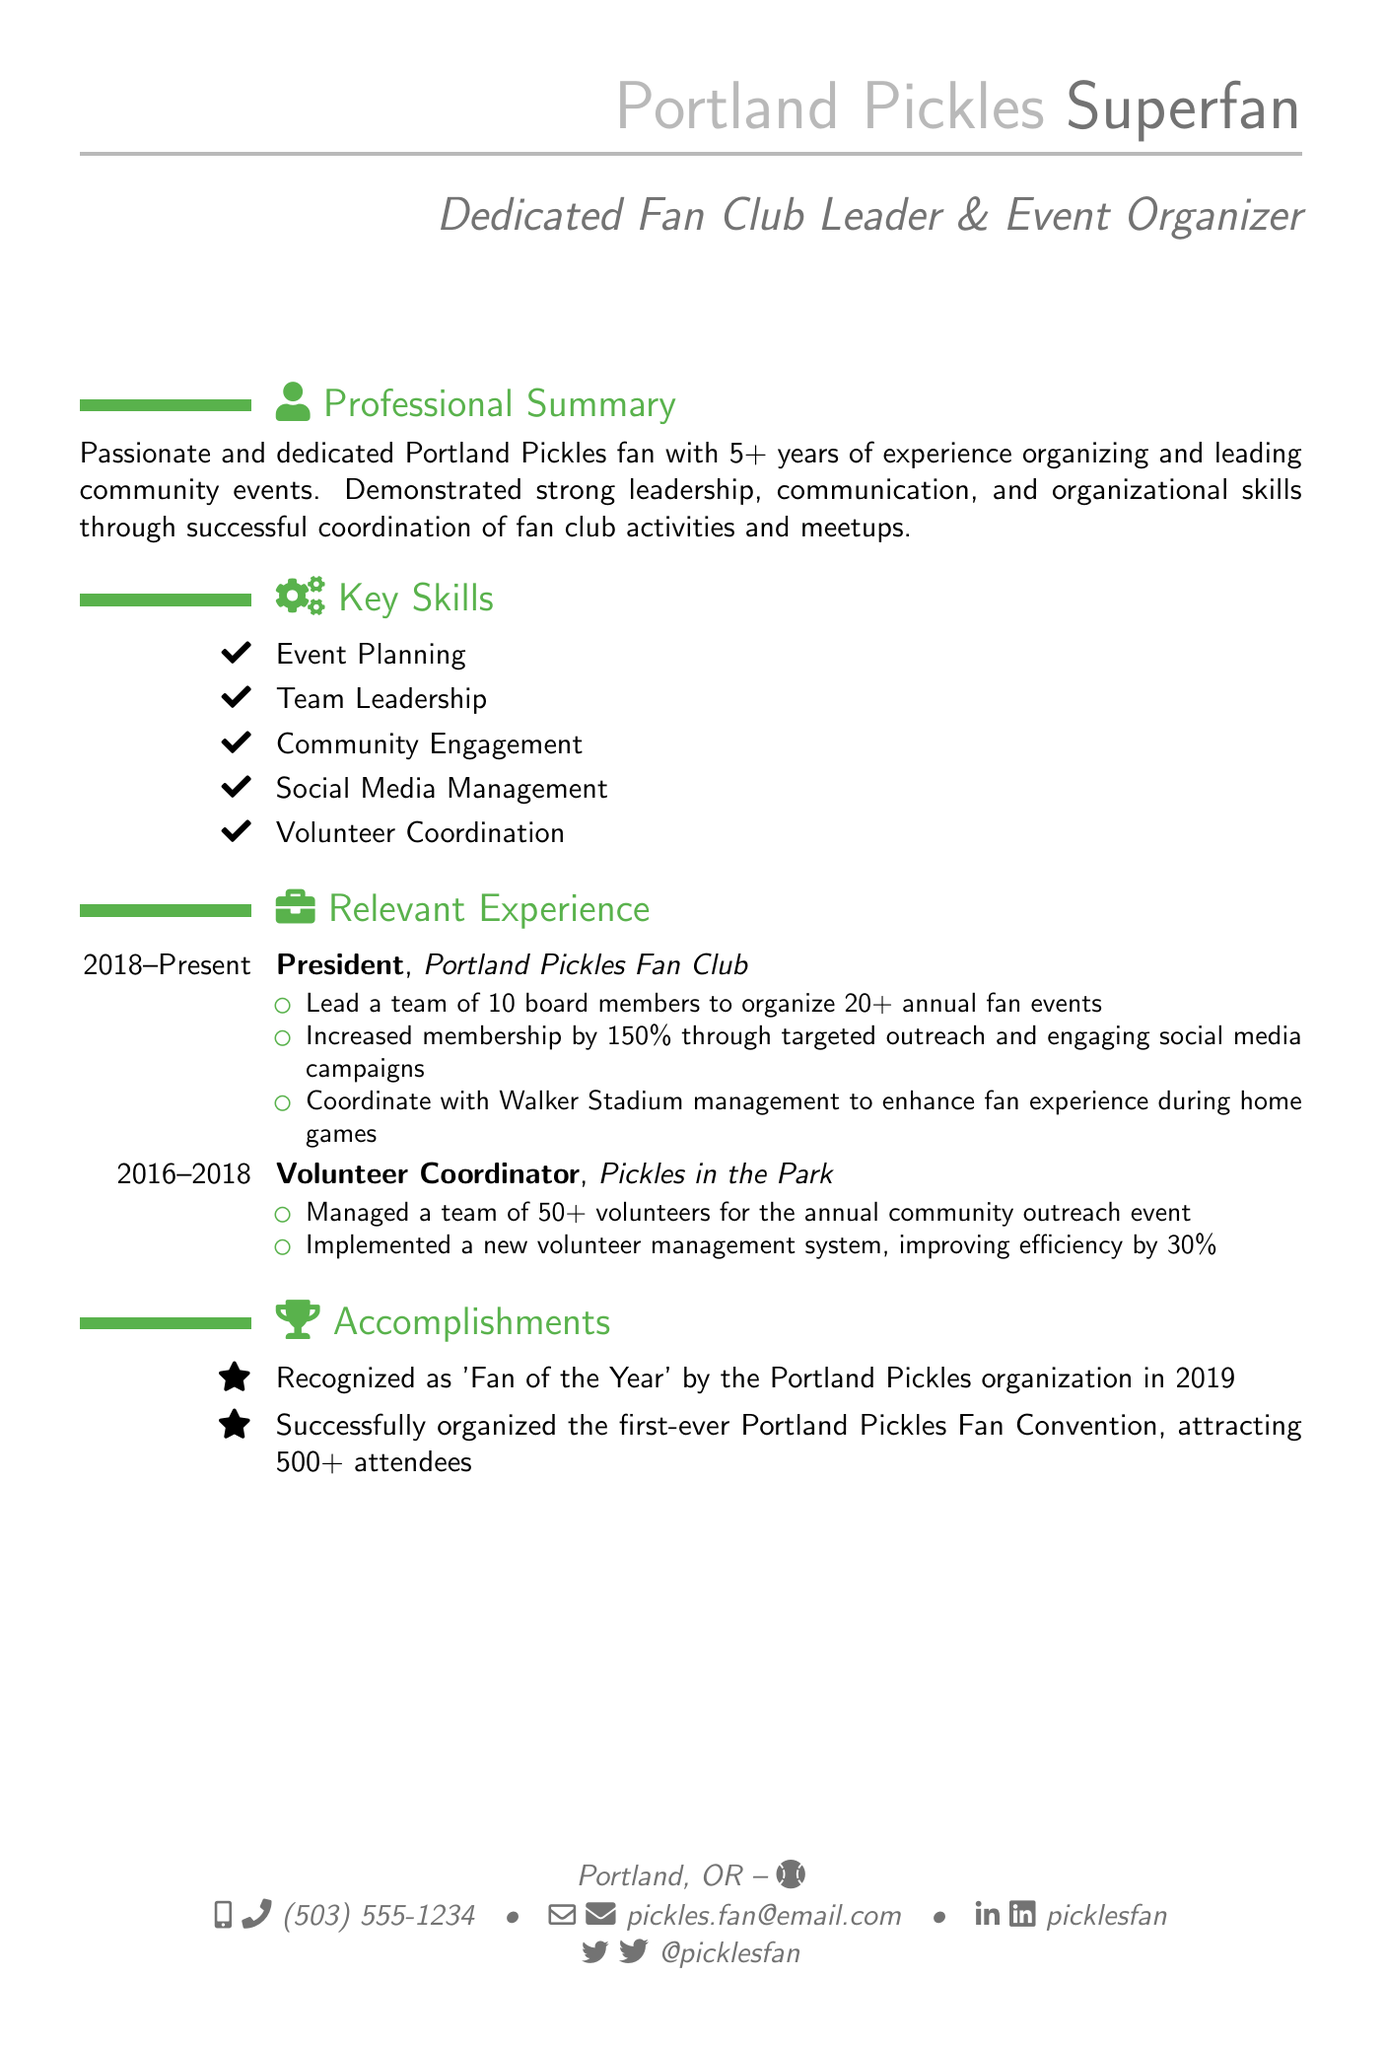What is the title of the position held at the Portland Pickles Fan Club? The title of the position held is indicated in the relevant experience section, which is "President."
Answer: President How many annual fan events are organized by the President? The number of annual fan events organized by the President is detailed in the responsibilities, which states "20+ annual fan events."
Answer: 20+ What percentage increase in membership was achieved? The percentage increase in membership is mentioned in the responsibilities as "150% through targeted outreach."
Answer: 150% What is one of the key skills listed in the resume? One of the key skills is highlighted under the key skills section, for example, "Event Planning."
Answer: Event Planning How many volunteers were managed during the Pickles in the Park event? The number of volunteers managed is specified in the relevant experience section as "50+ volunteers."
Answer: 50+ What recognition was received in 2019? The recognition received is stated in the accomplishments section, which mentions being "recognized as 'Fan of the Year' by the Portland Pickles organization."
Answer: Fan of the Year In what year did the President position at the Portland Pickles Fan Club begin? The starting year is provided in the relevant experience section and is noted as 2018.
Answer: 2018 What system was implemented to improve volunteer management? The system that was implemented is outlined in the relevant experience and referred to as a "new volunteer management system."
Answer: new volunteer management system How many attendees were at the first-ever Portland Pickles Fan Convention? The number of attendees is mentioned in the accomplishments section, which states "attracting 500+ attendees."
Answer: 500+ 